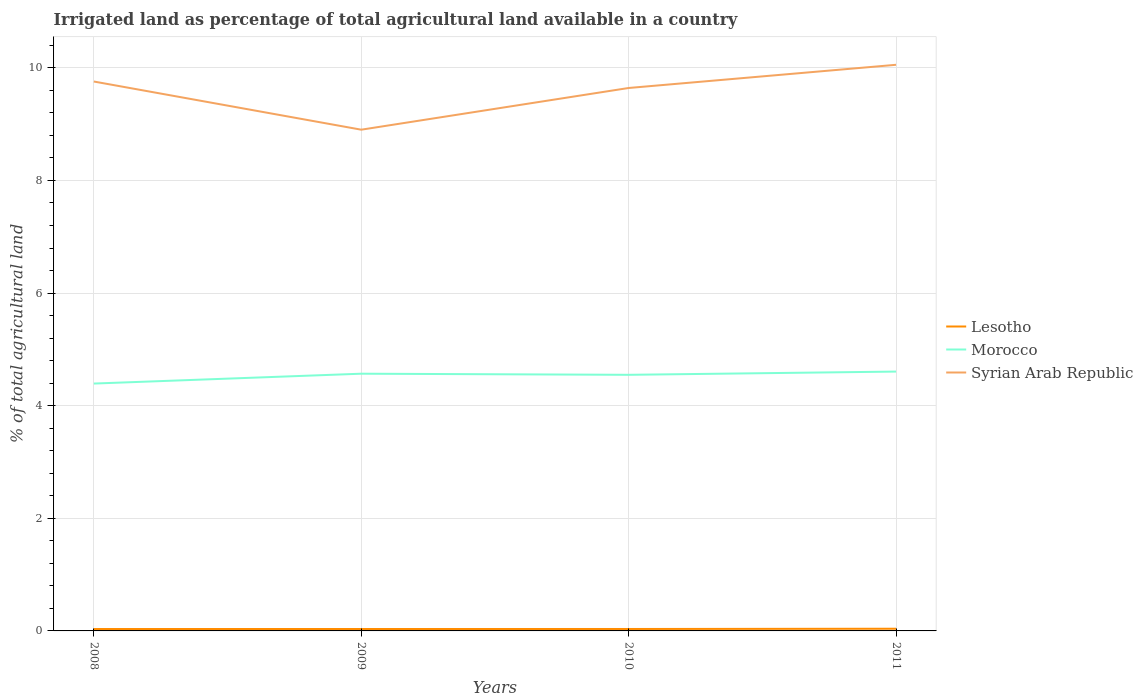Across all years, what is the maximum percentage of irrigated land in Lesotho?
Keep it short and to the point. 0.03. In which year was the percentage of irrigated land in Lesotho maximum?
Keep it short and to the point. 2008. What is the total percentage of irrigated land in Syrian Arab Republic in the graph?
Your response must be concise. -0.41. What is the difference between the highest and the second highest percentage of irrigated land in Morocco?
Offer a very short reply. 0.21. What is the difference between the highest and the lowest percentage of irrigated land in Morocco?
Your response must be concise. 3. How many years are there in the graph?
Keep it short and to the point. 4. Are the values on the major ticks of Y-axis written in scientific E-notation?
Ensure brevity in your answer.  No. Does the graph contain any zero values?
Offer a very short reply. No. Does the graph contain grids?
Ensure brevity in your answer.  Yes. What is the title of the graph?
Offer a very short reply. Irrigated land as percentage of total agricultural land available in a country. Does "Serbia" appear as one of the legend labels in the graph?
Provide a short and direct response. No. What is the label or title of the X-axis?
Give a very brief answer. Years. What is the label or title of the Y-axis?
Provide a succinct answer. % of total agricultural land. What is the % of total agricultural land of Lesotho in 2008?
Make the answer very short. 0.03. What is the % of total agricultural land of Morocco in 2008?
Offer a very short reply. 4.39. What is the % of total agricultural land of Syrian Arab Republic in 2008?
Provide a short and direct response. 9.76. What is the % of total agricultural land of Lesotho in 2009?
Give a very brief answer. 0.03. What is the % of total agricultural land in Morocco in 2009?
Your answer should be compact. 4.57. What is the % of total agricultural land of Syrian Arab Republic in 2009?
Your answer should be very brief. 8.9. What is the % of total agricultural land of Lesotho in 2010?
Ensure brevity in your answer.  0.03. What is the % of total agricultural land in Morocco in 2010?
Provide a short and direct response. 4.55. What is the % of total agricultural land in Syrian Arab Republic in 2010?
Make the answer very short. 9.64. What is the % of total agricultural land in Lesotho in 2011?
Give a very brief answer. 0.04. What is the % of total agricultural land in Morocco in 2011?
Give a very brief answer. 4.61. What is the % of total agricultural land in Syrian Arab Republic in 2011?
Provide a succinct answer. 10.05. Across all years, what is the maximum % of total agricultural land in Lesotho?
Offer a very short reply. 0.04. Across all years, what is the maximum % of total agricultural land of Morocco?
Give a very brief answer. 4.61. Across all years, what is the maximum % of total agricultural land of Syrian Arab Republic?
Provide a short and direct response. 10.05. Across all years, what is the minimum % of total agricultural land of Lesotho?
Provide a short and direct response. 0.03. Across all years, what is the minimum % of total agricultural land of Morocco?
Provide a succinct answer. 4.39. Across all years, what is the minimum % of total agricultural land of Syrian Arab Republic?
Offer a very short reply. 8.9. What is the total % of total agricultural land in Lesotho in the graph?
Provide a succinct answer. 0.14. What is the total % of total agricultural land of Morocco in the graph?
Make the answer very short. 18.11. What is the total % of total agricultural land of Syrian Arab Republic in the graph?
Provide a short and direct response. 38.35. What is the difference between the % of total agricultural land in Lesotho in 2008 and that in 2009?
Provide a succinct answer. -0. What is the difference between the % of total agricultural land in Morocco in 2008 and that in 2009?
Ensure brevity in your answer.  -0.18. What is the difference between the % of total agricultural land in Syrian Arab Republic in 2008 and that in 2009?
Keep it short and to the point. 0.86. What is the difference between the % of total agricultural land of Lesotho in 2008 and that in 2010?
Your response must be concise. -0. What is the difference between the % of total agricultural land of Morocco in 2008 and that in 2010?
Keep it short and to the point. -0.16. What is the difference between the % of total agricultural land of Syrian Arab Republic in 2008 and that in 2010?
Make the answer very short. 0.11. What is the difference between the % of total agricultural land in Lesotho in 2008 and that in 2011?
Give a very brief answer. -0.01. What is the difference between the % of total agricultural land of Morocco in 2008 and that in 2011?
Offer a terse response. -0.21. What is the difference between the % of total agricultural land of Syrian Arab Republic in 2008 and that in 2011?
Give a very brief answer. -0.3. What is the difference between the % of total agricultural land of Lesotho in 2009 and that in 2010?
Provide a succinct answer. -0. What is the difference between the % of total agricultural land of Morocco in 2009 and that in 2010?
Your response must be concise. 0.02. What is the difference between the % of total agricultural land in Syrian Arab Republic in 2009 and that in 2010?
Make the answer very short. -0.74. What is the difference between the % of total agricultural land of Lesotho in 2009 and that in 2011?
Make the answer very short. -0. What is the difference between the % of total agricultural land in Morocco in 2009 and that in 2011?
Give a very brief answer. -0.04. What is the difference between the % of total agricultural land in Syrian Arab Republic in 2009 and that in 2011?
Your answer should be very brief. -1.15. What is the difference between the % of total agricultural land of Lesotho in 2010 and that in 2011?
Give a very brief answer. -0. What is the difference between the % of total agricultural land in Morocco in 2010 and that in 2011?
Your response must be concise. -0.06. What is the difference between the % of total agricultural land in Syrian Arab Republic in 2010 and that in 2011?
Offer a terse response. -0.41. What is the difference between the % of total agricultural land in Lesotho in 2008 and the % of total agricultural land in Morocco in 2009?
Your answer should be compact. -4.53. What is the difference between the % of total agricultural land in Lesotho in 2008 and the % of total agricultural land in Syrian Arab Republic in 2009?
Keep it short and to the point. -8.87. What is the difference between the % of total agricultural land of Morocco in 2008 and the % of total agricultural land of Syrian Arab Republic in 2009?
Ensure brevity in your answer.  -4.51. What is the difference between the % of total agricultural land in Lesotho in 2008 and the % of total agricultural land in Morocco in 2010?
Make the answer very short. -4.51. What is the difference between the % of total agricultural land of Lesotho in 2008 and the % of total agricultural land of Syrian Arab Republic in 2010?
Offer a terse response. -9.61. What is the difference between the % of total agricultural land of Morocco in 2008 and the % of total agricultural land of Syrian Arab Republic in 2010?
Make the answer very short. -5.25. What is the difference between the % of total agricultural land in Lesotho in 2008 and the % of total agricultural land in Morocco in 2011?
Keep it short and to the point. -4.57. What is the difference between the % of total agricultural land in Lesotho in 2008 and the % of total agricultural land in Syrian Arab Republic in 2011?
Offer a terse response. -10.02. What is the difference between the % of total agricultural land in Morocco in 2008 and the % of total agricultural land in Syrian Arab Republic in 2011?
Your response must be concise. -5.66. What is the difference between the % of total agricultural land in Lesotho in 2009 and the % of total agricultural land in Morocco in 2010?
Offer a terse response. -4.51. What is the difference between the % of total agricultural land in Lesotho in 2009 and the % of total agricultural land in Syrian Arab Republic in 2010?
Provide a succinct answer. -9.61. What is the difference between the % of total agricultural land of Morocco in 2009 and the % of total agricultural land of Syrian Arab Republic in 2010?
Offer a terse response. -5.07. What is the difference between the % of total agricultural land of Lesotho in 2009 and the % of total agricultural land of Morocco in 2011?
Your answer should be very brief. -4.57. What is the difference between the % of total agricultural land in Lesotho in 2009 and the % of total agricultural land in Syrian Arab Republic in 2011?
Provide a succinct answer. -10.02. What is the difference between the % of total agricultural land of Morocco in 2009 and the % of total agricultural land of Syrian Arab Republic in 2011?
Offer a terse response. -5.49. What is the difference between the % of total agricultural land of Lesotho in 2010 and the % of total agricultural land of Morocco in 2011?
Offer a very short reply. -4.57. What is the difference between the % of total agricultural land in Lesotho in 2010 and the % of total agricultural land in Syrian Arab Republic in 2011?
Offer a very short reply. -10.02. What is the difference between the % of total agricultural land in Morocco in 2010 and the % of total agricultural land in Syrian Arab Republic in 2011?
Your answer should be very brief. -5.51. What is the average % of total agricultural land of Lesotho per year?
Keep it short and to the point. 0.04. What is the average % of total agricultural land in Morocco per year?
Your answer should be compact. 4.53. What is the average % of total agricultural land of Syrian Arab Republic per year?
Make the answer very short. 9.59. In the year 2008, what is the difference between the % of total agricultural land of Lesotho and % of total agricultural land of Morocco?
Ensure brevity in your answer.  -4.36. In the year 2008, what is the difference between the % of total agricultural land in Lesotho and % of total agricultural land in Syrian Arab Republic?
Provide a short and direct response. -9.72. In the year 2008, what is the difference between the % of total agricultural land of Morocco and % of total agricultural land of Syrian Arab Republic?
Provide a short and direct response. -5.36. In the year 2009, what is the difference between the % of total agricultural land of Lesotho and % of total agricultural land of Morocco?
Your answer should be very brief. -4.53. In the year 2009, what is the difference between the % of total agricultural land in Lesotho and % of total agricultural land in Syrian Arab Republic?
Your response must be concise. -8.87. In the year 2009, what is the difference between the % of total agricultural land in Morocco and % of total agricultural land in Syrian Arab Republic?
Offer a very short reply. -4.33. In the year 2010, what is the difference between the % of total agricultural land in Lesotho and % of total agricultural land in Morocco?
Provide a succinct answer. -4.51. In the year 2010, what is the difference between the % of total agricultural land of Lesotho and % of total agricultural land of Syrian Arab Republic?
Offer a very short reply. -9.61. In the year 2010, what is the difference between the % of total agricultural land of Morocco and % of total agricultural land of Syrian Arab Republic?
Keep it short and to the point. -5.09. In the year 2011, what is the difference between the % of total agricultural land of Lesotho and % of total agricultural land of Morocco?
Offer a very short reply. -4.57. In the year 2011, what is the difference between the % of total agricultural land in Lesotho and % of total agricultural land in Syrian Arab Republic?
Provide a short and direct response. -10.02. In the year 2011, what is the difference between the % of total agricultural land of Morocco and % of total agricultural land of Syrian Arab Republic?
Provide a succinct answer. -5.45. What is the ratio of the % of total agricultural land of Lesotho in 2008 to that in 2009?
Make the answer very short. 0.99. What is the ratio of the % of total agricultural land of Morocco in 2008 to that in 2009?
Your answer should be compact. 0.96. What is the ratio of the % of total agricultural land in Syrian Arab Republic in 2008 to that in 2009?
Your response must be concise. 1.1. What is the ratio of the % of total agricultural land of Morocco in 2008 to that in 2010?
Ensure brevity in your answer.  0.97. What is the ratio of the % of total agricultural land in Syrian Arab Republic in 2008 to that in 2010?
Offer a terse response. 1.01. What is the ratio of the % of total agricultural land of Lesotho in 2008 to that in 2011?
Give a very brief answer. 0.87. What is the ratio of the % of total agricultural land in Morocco in 2008 to that in 2011?
Ensure brevity in your answer.  0.95. What is the ratio of the % of total agricultural land of Syrian Arab Republic in 2008 to that in 2011?
Offer a very short reply. 0.97. What is the ratio of the % of total agricultural land in Syrian Arab Republic in 2009 to that in 2010?
Provide a succinct answer. 0.92. What is the ratio of the % of total agricultural land in Lesotho in 2009 to that in 2011?
Ensure brevity in your answer.  0.88. What is the ratio of the % of total agricultural land of Syrian Arab Republic in 2009 to that in 2011?
Offer a very short reply. 0.89. What is the ratio of the % of total agricultural land of Lesotho in 2010 to that in 2011?
Provide a succinct answer. 0.88. What is the ratio of the % of total agricultural land in Morocco in 2010 to that in 2011?
Keep it short and to the point. 0.99. What is the ratio of the % of total agricultural land in Syrian Arab Republic in 2010 to that in 2011?
Provide a succinct answer. 0.96. What is the difference between the highest and the second highest % of total agricultural land in Lesotho?
Your response must be concise. 0. What is the difference between the highest and the second highest % of total agricultural land in Morocco?
Provide a short and direct response. 0.04. What is the difference between the highest and the second highest % of total agricultural land of Syrian Arab Republic?
Keep it short and to the point. 0.3. What is the difference between the highest and the lowest % of total agricultural land of Lesotho?
Your answer should be compact. 0.01. What is the difference between the highest and the lowest % of total agricultural land in Morocco?
Offer a very short reply. 0.21. What is the difference between the highest and the lowest % of total agricultural land of Syrian Arab Republic?
Provide a short and direct response. 1.15. 